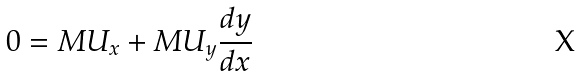Convert formula to latex. <formula><loc_0><loc_0><loc_500><loc_500>0 = M U _ { x } + M U _ { y } \frac { d y } { d x }</formula> 